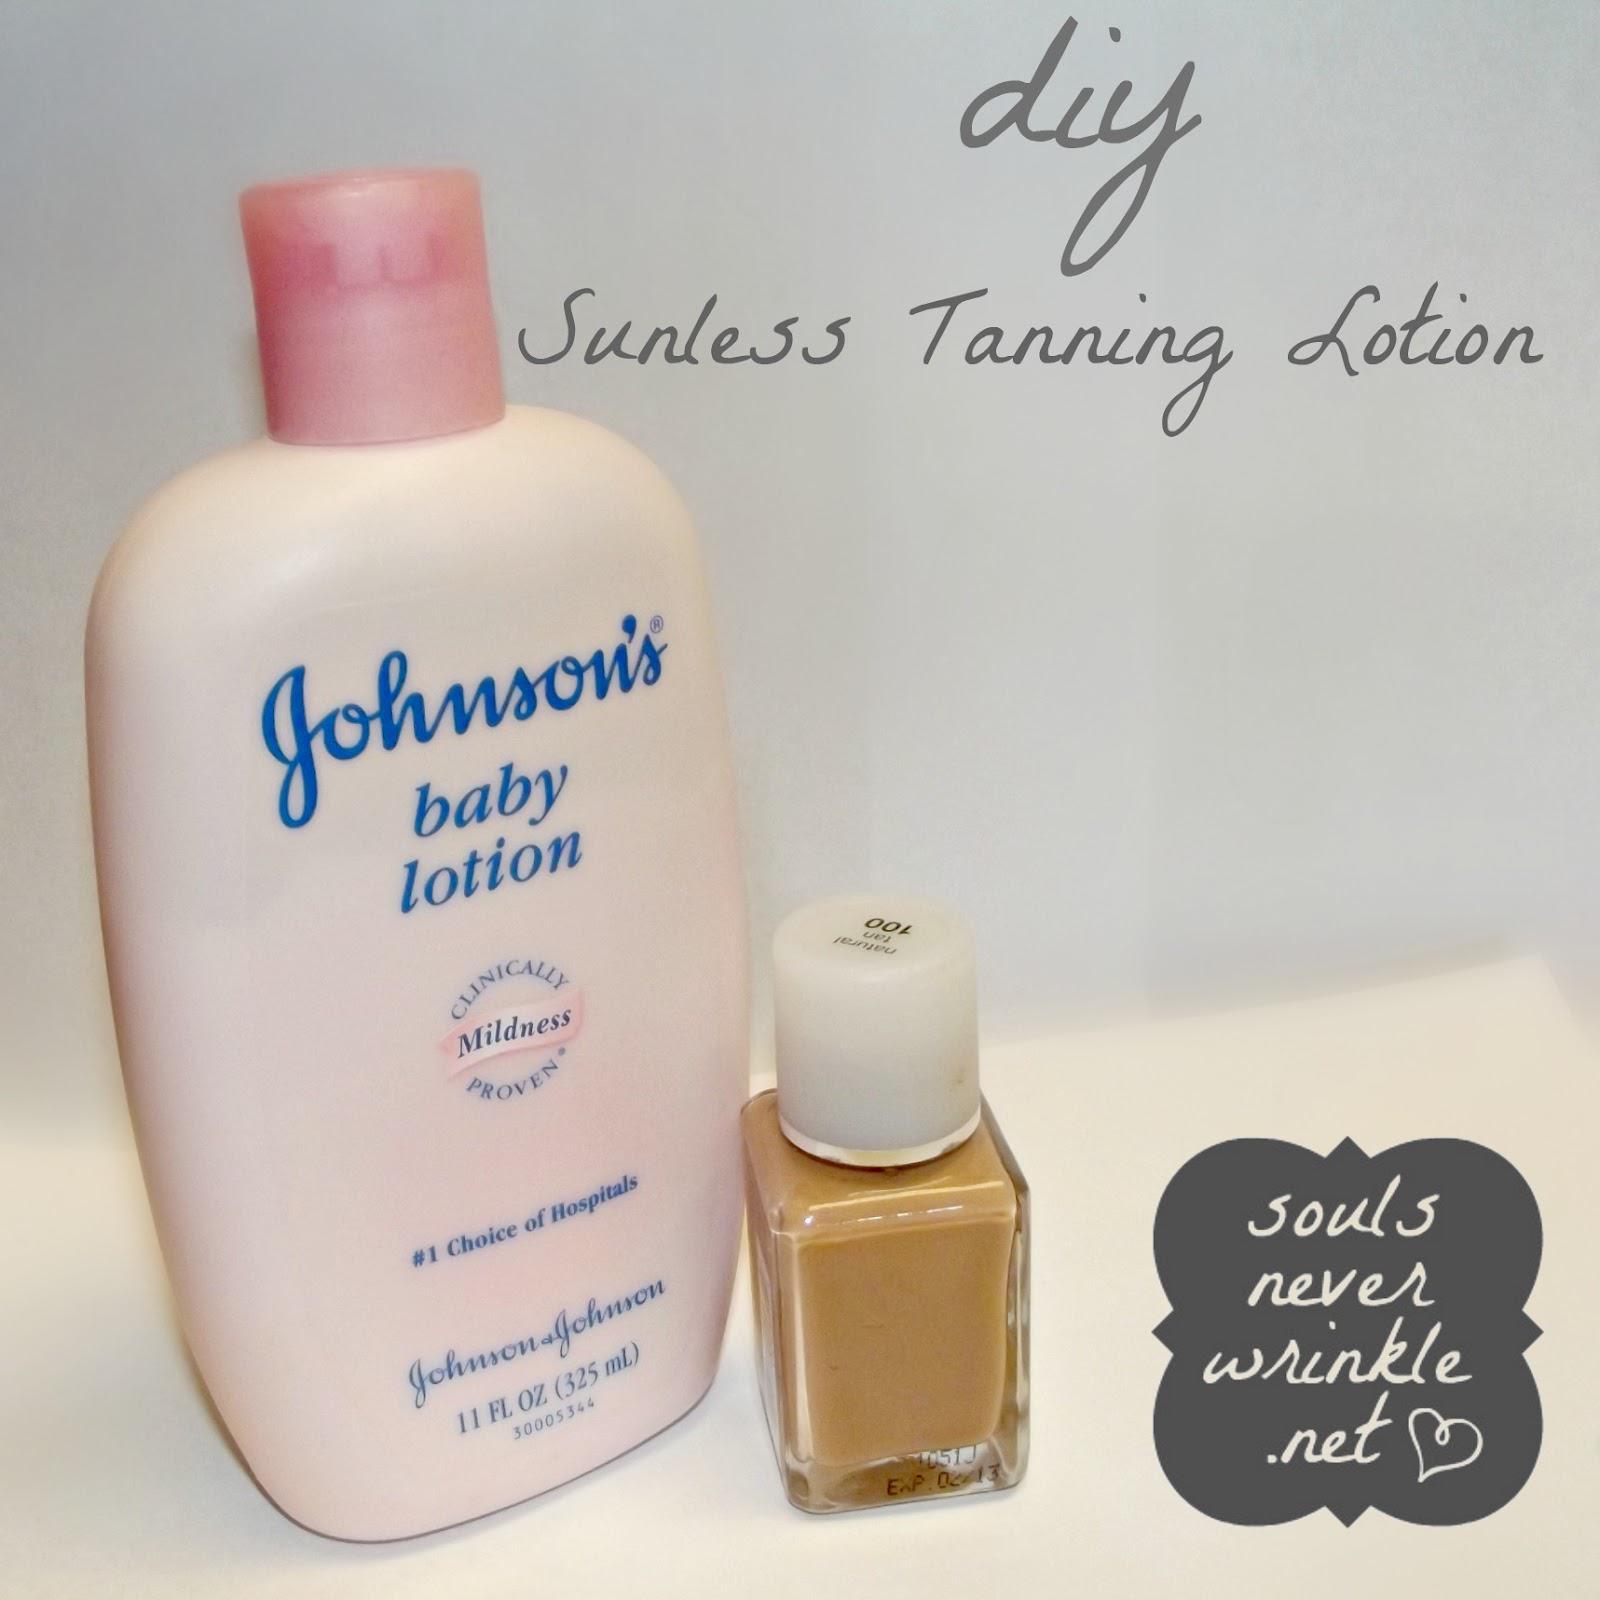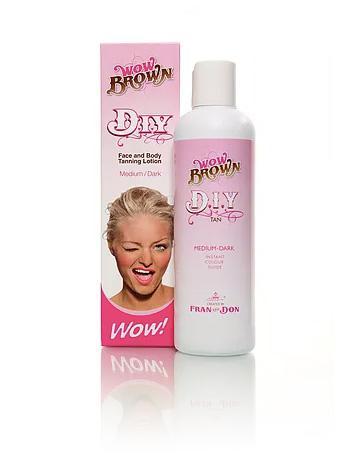The first image is the image on the left, the second image is the image on the right. Given the left and right images, does the statement "An image includes multiple clear containers filled with white and brown substances." hold true? Answer yes or no. No. The first image is the image on the left, the second image is the image on the right. For the images shown, is this caption "Powder sits in a glass bowl in one of the images." true? Answer yes or no. No. 